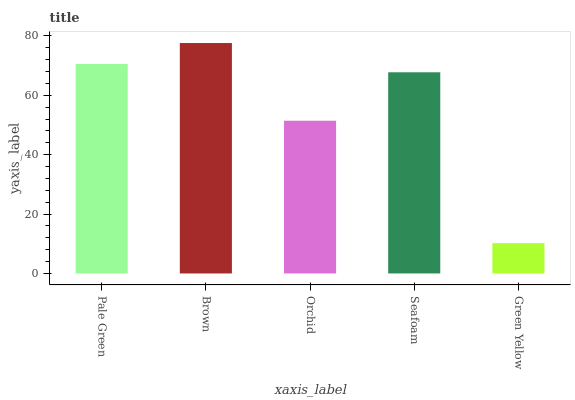Is Green Yellow the minimum?
Answer yes or no. Yes. Is Brown the maximum?
Answer yes or no. Yes. Is Orchid the minimum?
Answer yes or no. No. Is Orchid the maximum?
Answer yes or no. No. Is Brown greater than Orchid?
Answer yes or no. Yes. Is Orchid less than Brown?
Answer yes or no. Yes. Is Orchid greater than Brown?
Answer yes or no. No. Is Brown less than Orchid?
Answer yes or no. No. Is Seafoam the high median?
Answer yes or no. Yes. Is Seafoam the low median?
Answer yes or no. Yes. Is Green Yellow the high median?
Answer yes or no. No. Is Green Yellow the low median?
Answer yes or no. No. 